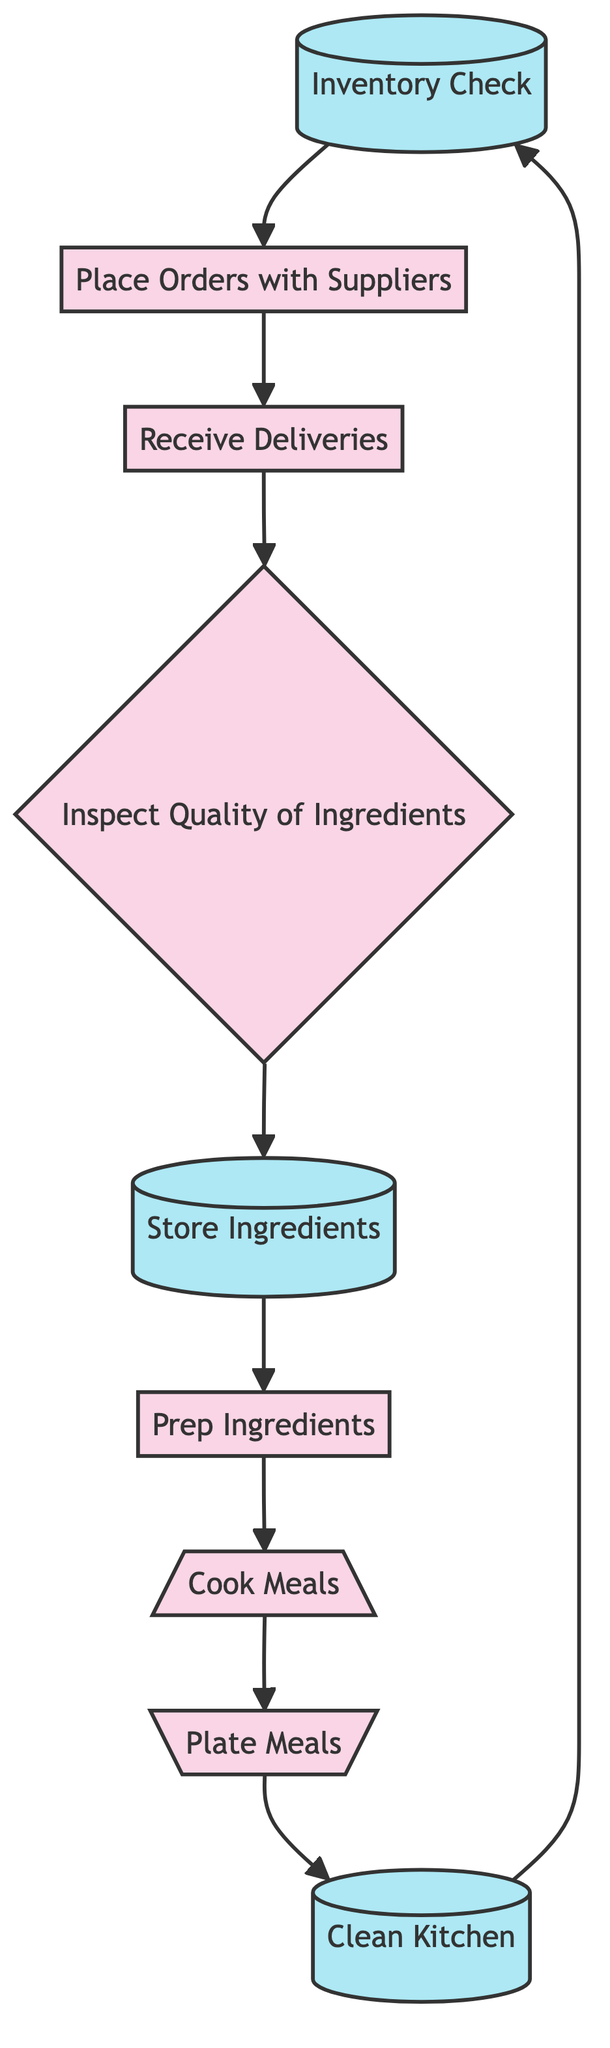What is the first task in the diagram? The first task in the diagram, indicated by the starting point, is "Inventory Check."
Answer: Inventory Check How many tasks are there in total? By counting the nodes, there are nine tasks represented in the diagram: Inventory Check, Place Orders with Suppliers, Receive Deliveries, Inspect Quality of Ingredients, Store Ingredients, Prep Ingredients, Cook Meals, Plate Meals, and Clean Kitchen.
Answer: Nine What task follows "Cook Meals"? The task that follows "Cook Meals" in the directed flow of the diagram is "Plate Meals."
Answer: Plate Meals Which task is connected to "Inspect Quality of Ingredients"? "Inspect Quality of Ingredients" is connected to "Store Ingredients," as it flows to this task next in the process.
Answer: Store Ingredients What is the last task in the cycle? The last task in the cycle, just before returning to the first task, is "Clean Kitchen."
Answer: Clean Kitchen How does the workflow cycle back to the beginning? The workflow cycles back to the beginning by having "Clean Kitchen" leading back to "Inventory Check," completing the task flow.
Answer: Through Clean Kitchen What is the relationship between "Receive Deliveries" and "Inspect Quality of Ingredients"? "Receive Deliveries" leads directly to "Inspect Quality of Ingredients," indicating that the next step after receiving deliveries is to inspect the quality of ingredients.
Answer: Leads to Which task is processed right after storing ingredients? The task immediately processed after "Store Ingredients" is "Prep Ingredients."
Answer: Prep Ingredients What is the total number of edges in the diagram? The total number of directed edges connecting the nodes in the diagram is eight, as each task flows to the next in sequence.
Answer: Eight 